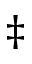Convert formula to latex. <formula><loc_0><loc_0><loc_500><loc_500>\ddagger</formula> 